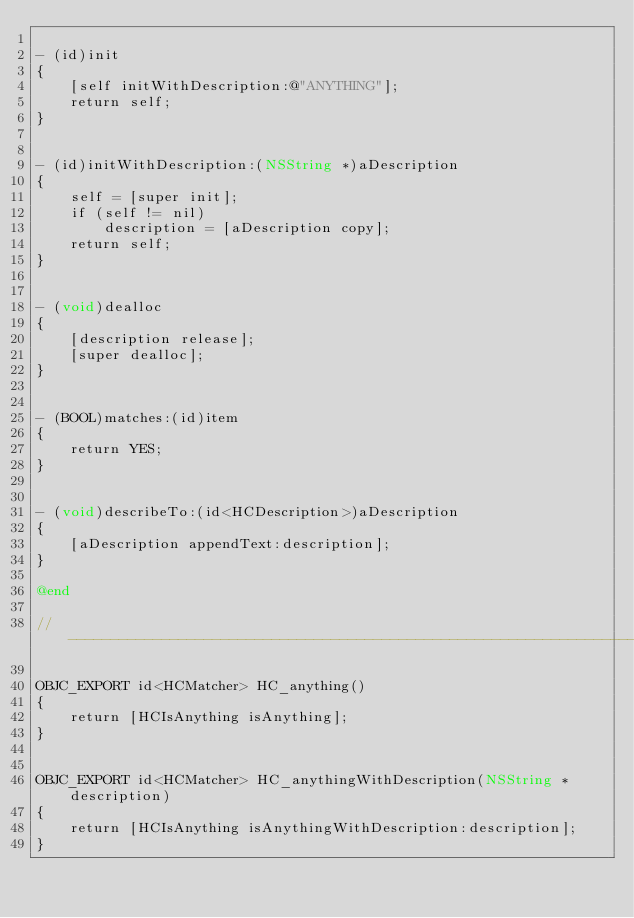<code> <loc_0><loc_0><loc_500><loc_500><_ObjectiveC_>
- (id)init
{
    [self initWithDescription:@"ANYTHING"];
    return self;
}


- (id)initWithDescription:(NSString *)aDescription
{
    self = [super init];
    if (self != nil)
        description = [aDescription copy];
    return self;
}


- (void)dealloc
{
    [description release];
    [super dealloc];
}


- (BOOL)matches:(id)item
{
    return YES;
}


- (void)describeTo:(id<HCDescription>)aDescription
{
    [aDescription appendText:description];
}

@end

//--------------------------------------------------------------------------------------------------

OBJC_EXPORT id<HCMatcher> HC_anything()
{
    return [HCIsAnything isAnything];
}


OBJC_EXPORT id<HCMatcher> HC_anythingWithDescription(NSString *description)
{
    return [HCIsAnything isAnythingWithDescription:description];
}
</code> 